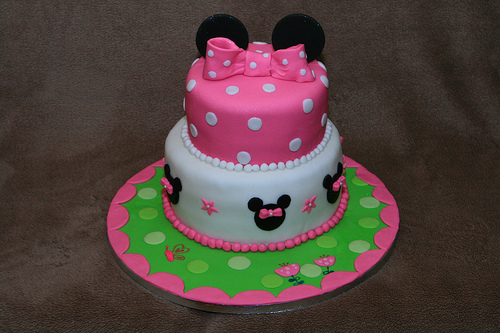<image>
Is there a bow on the table? No. The bow is not positioned on the table. They may be near each other, but the bow is not supported by or resting on top of the table. Where is the cake in relation to the table? Is it in the table? No. The cake is not contained within the table. These objects have a different spatial relationship. 